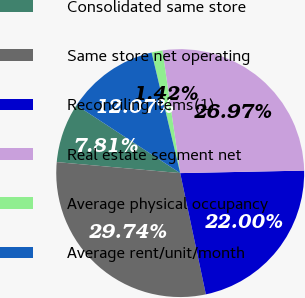Convert chart. <chart><loc_0><loc_0><loc_500><loc_500><pie_chart><fcel>Consolidated same store<fcel>Same store net operating<fcel>Reconciling items(1)<fcel>Real estate segment net<fcel>Average physical occupancy<fcel>Average rent/unit/month<nl><fcel>7.81%<fcel>29.74%<fcel>22.0%<fcel>26.97%<fcel>1.42%<fcel>12.07%<nl></chart> 